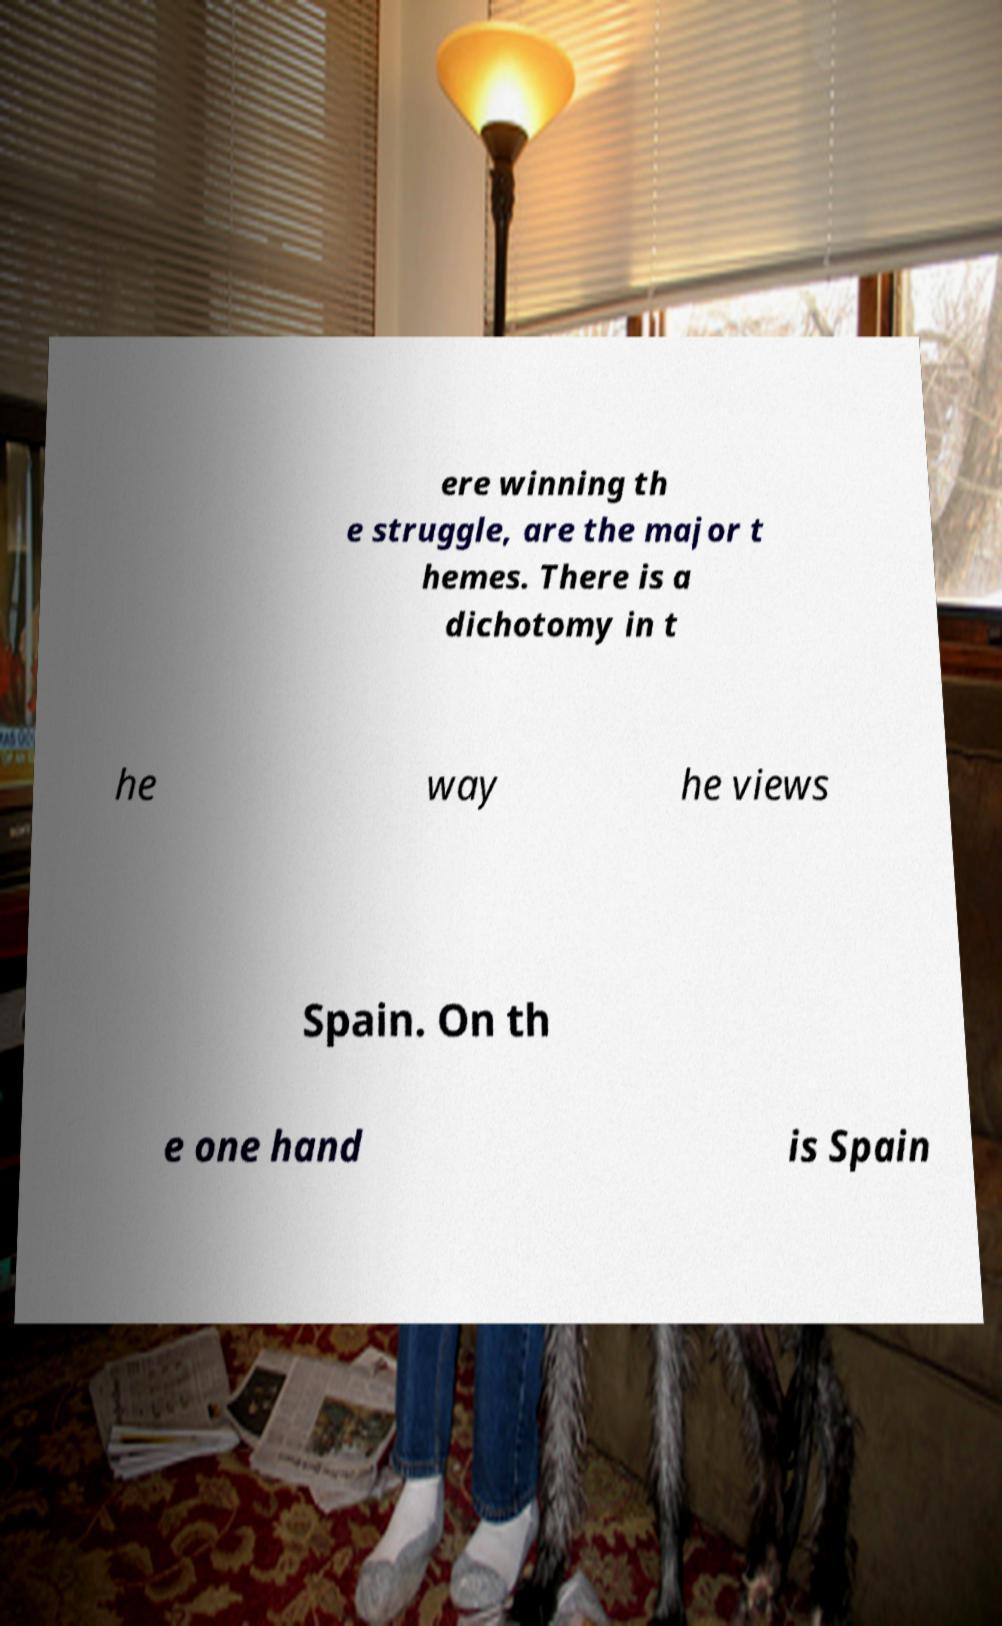Please read and relay the text visible in this image. What does it say? ere winning th e struggle, are the major t hemes. There is a dichotomy in t he way he views Spain. On th e one hand is Spain 